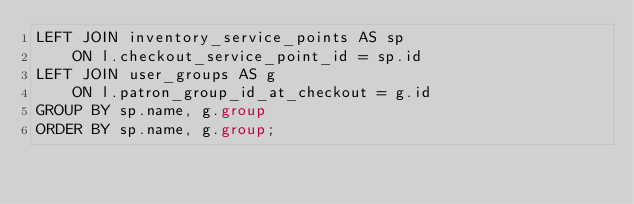Convert code to text. <code><loc_0><loc_0><loc_500><loc_500><_SQL_>LEFT JOIN inventory_service_points AS sp
    ON l.checkout_service_point_id = sp.id
LEFT JOIN user_groups AS g
    ON l.patron_group_id_at_checkout = g.id
GROUP BY sp.name, g.group
ORDER BY sp.name, g.group;
</code> 